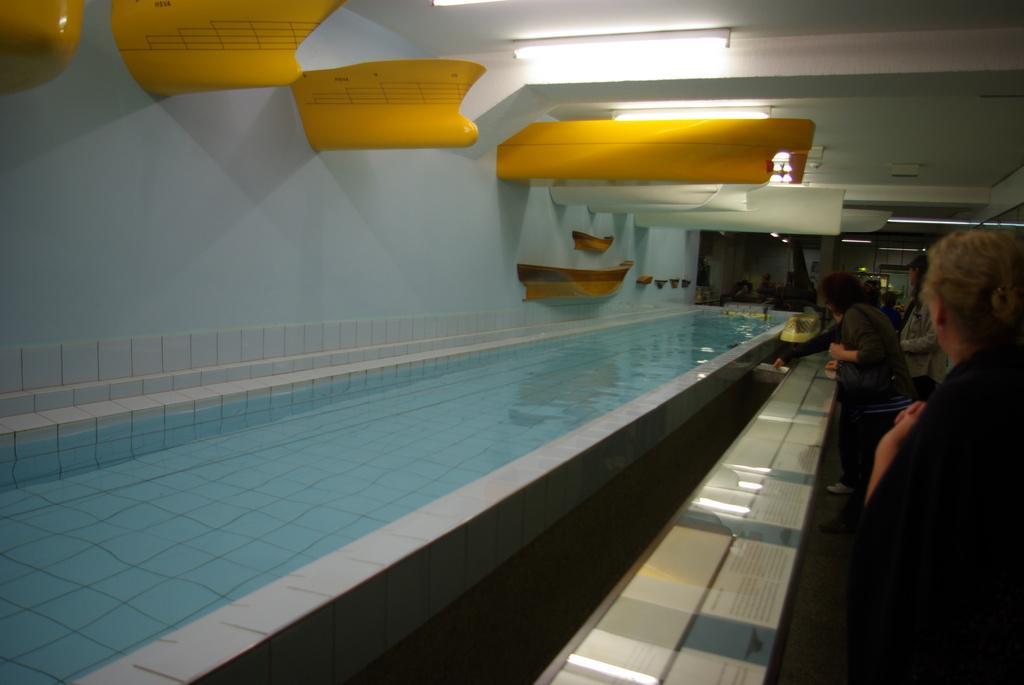How would you summarize this image in a sentence or two? In this image I can see the water and I can see few persons standing. In the background I can see few lights and the roof is in white color and I can see few yellow color objects. 